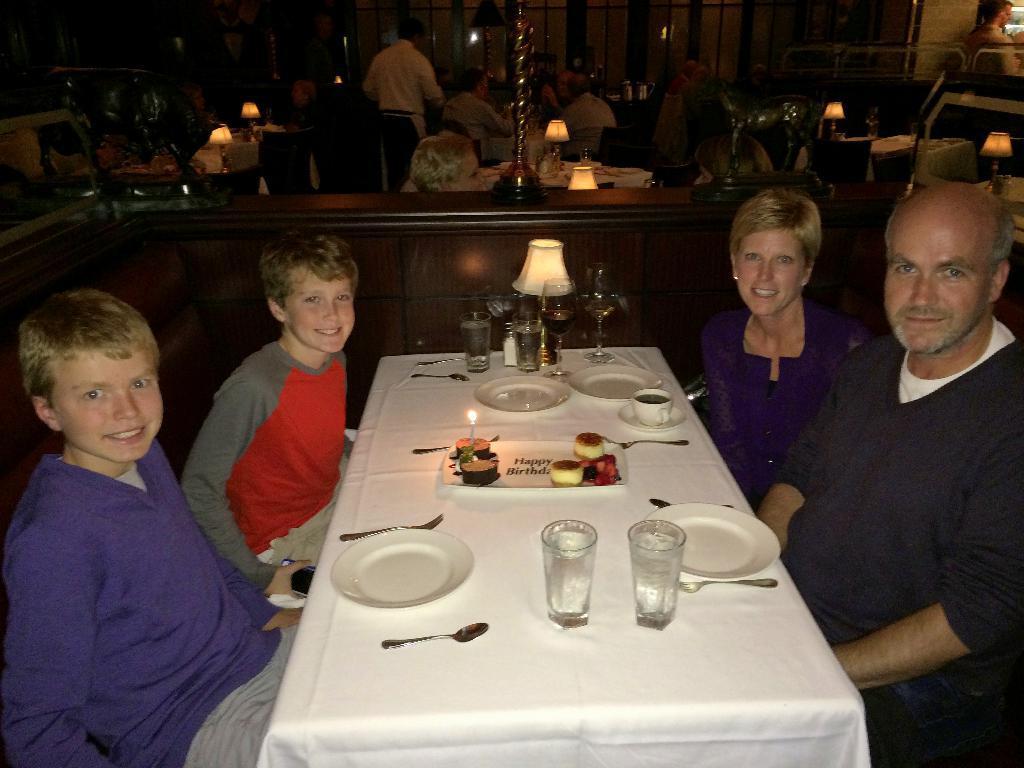Could you give a brief overview of what you see in this image? in the picture we can see a restaurant,here we can four persons in with two are children and two are adult sitting in a chair,there is a table in front of them in which we can see spoons,plates,glasses along with the liquid and we can also see a table lamp on the table. 